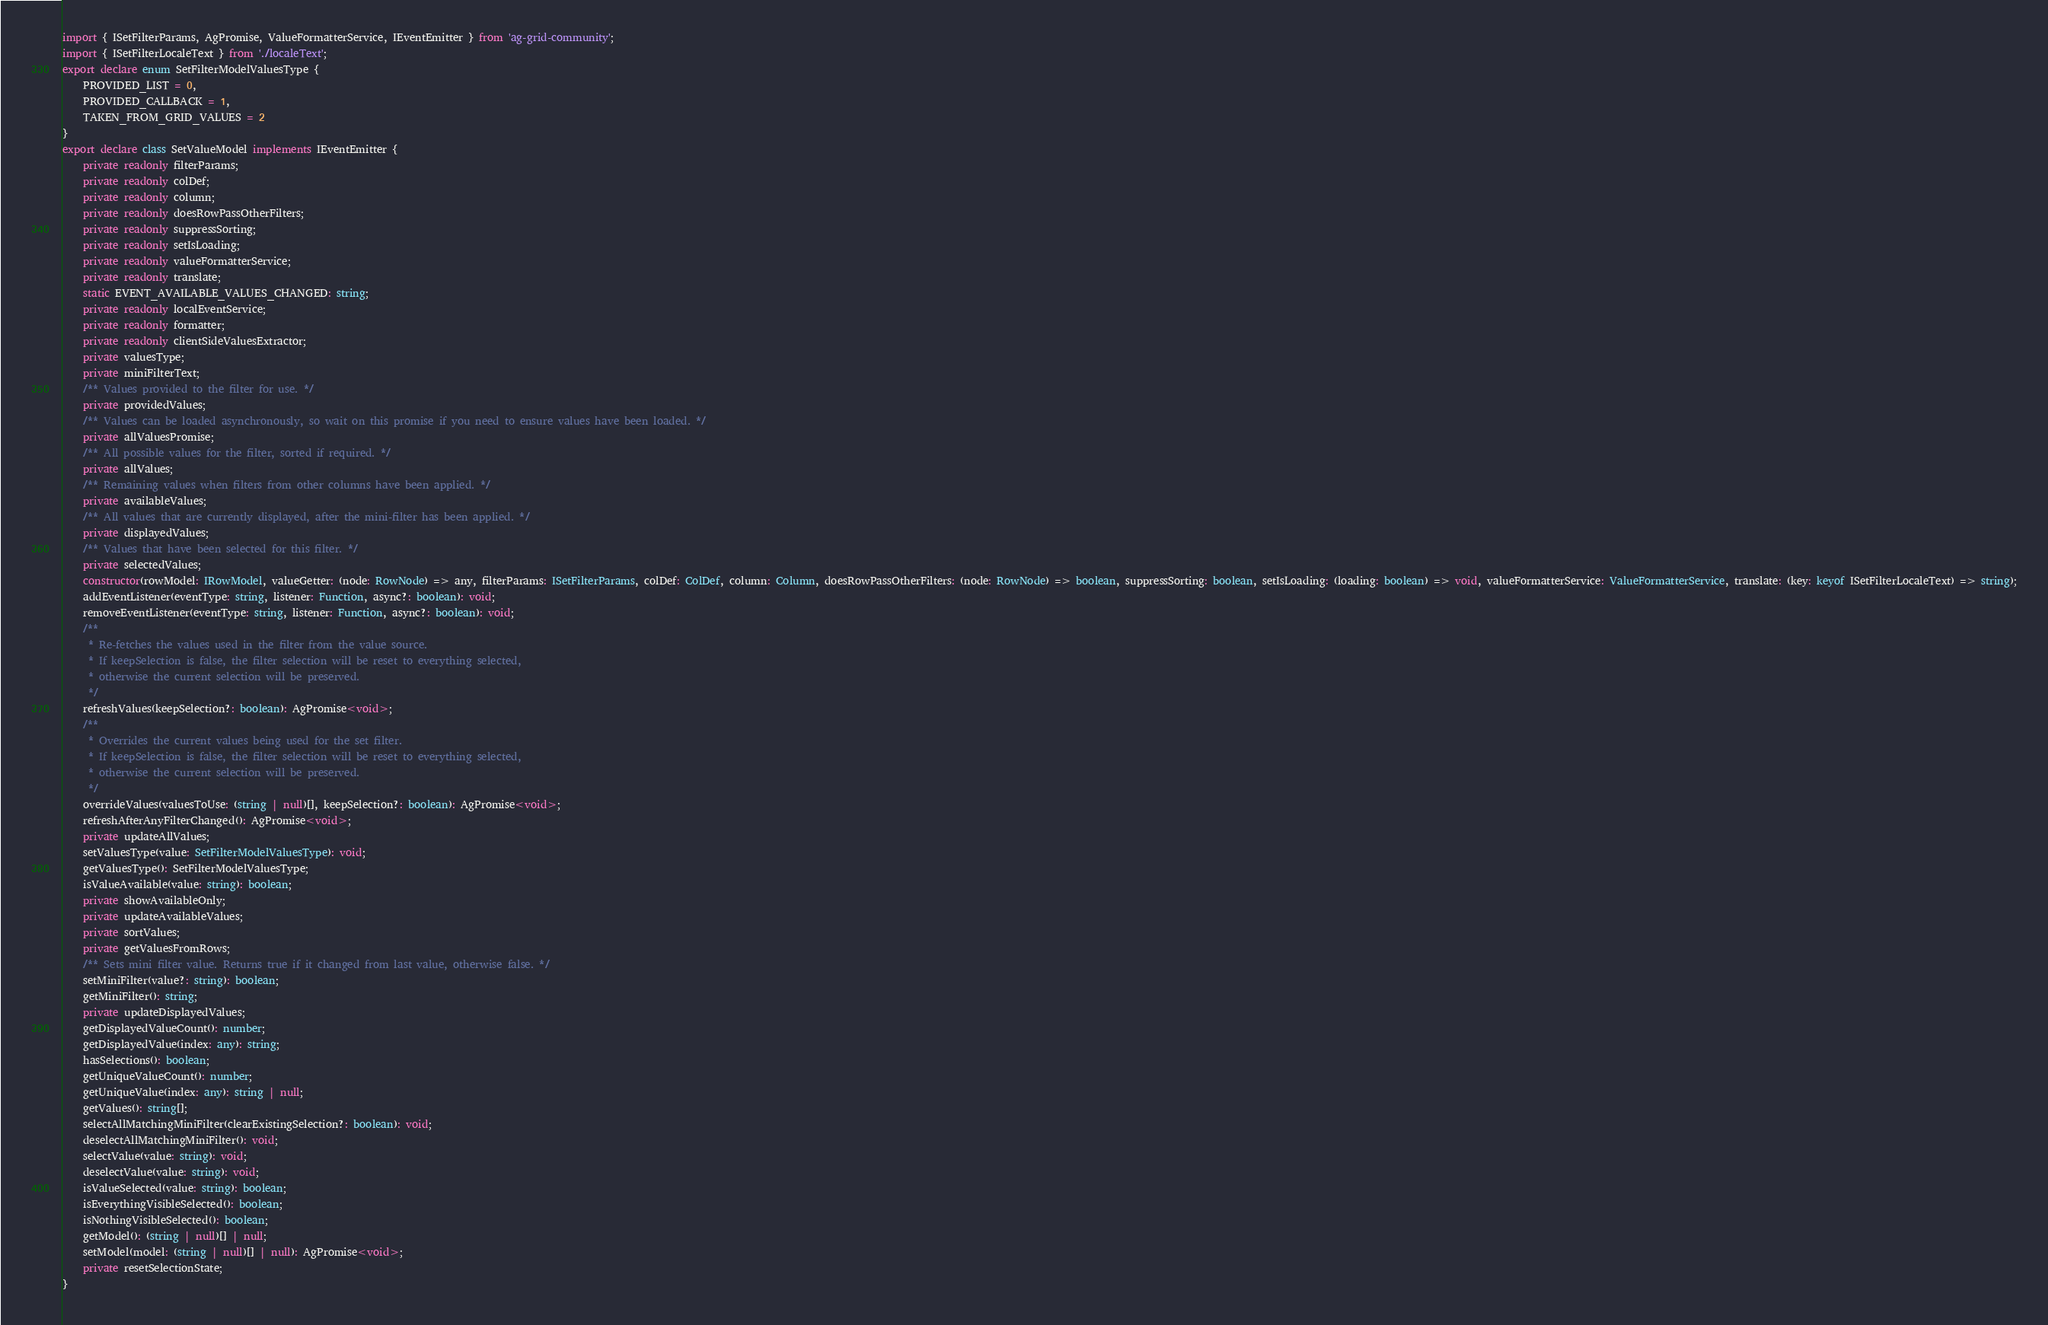<code> <loc_0><loc_0><loc_500><loc_500><_TypeScript_>import { ISetFilterParams, AgPromise, ValueFormatterService, IEventEmitter } from 'ag-grid-community';
import { ISetFilterLocaleText } from './localeText';
export declare enum SetFilterModelValuesType {
    PROVIDED_LIST = 0,
    PROVIDED_CALLBACK = 1,
    TAKEN_FROM_GRID_VALUES = 2
}
export declare class SetValueModel implements IEventEmitter {
    private readonly filterParams;
    private readonly colDef;
    private readonly column;
    private readonly doesRowPassOtherFilters;
    private readonly suppressSorting;
    private readonly setIsLoading;
    private readonly valueFormatterService;
    private readonly translate;
    static EVENT_AVAILABLE_VALUES_CHANGED: string;
    private readonly localEventService;
    private readonly formatter;
    private readonly clientSideValuesExtractor;
    private valuesType;
    private miniFilterText;
    /** Values provided to the filter for use. */
    private providedValues;
    /** Values can be loaded asynchronously, so wait on this promise if you need to ensure values have been loaded. */
    private allValuesPromise;
    /** All possible values for the filter, sorted if required. */
    private allValues;
    /** Remaining values when filters from other columns have been applied. */
    private availableValues;
    /** All values that are currently displayed, after the mini-filter has been applied. */
    private displayedValues;
    /** Values that have been selected for this filter. */
    private selectedValues;
    constructor(rowModel: IRowModel, valueGetter: (node: RowNode) => any, filterParams: ISetFilterParams, colDef: ColDef, column: Column, doesRowPassOtherFilters: (node: RowNode) => boolean, suppressSorting: boolean, setIsLoading: (loading: boolean) => void, valueFormatterService: ValueFormatterService, translate: (key: keyof ISetFilterLocaleText) => string);
    addEventListener(eventType: string, listener: Function, async?: boolean): void;
    removeEventListener(eventType: string, listener: Function, async?: boolean): void;
    /**
     * Re-fetches the values used in the filter from the value source.
     * If keepSelection is false, the filter selection will be reset to everything selected,
     * otherwise the current selection will be preserved.
     */
    refreshValues(keepSelection?: boolean): AgPromise<void>;
    /**
     * Overrides the current values being used for the set filter.
     * If keepSelection is false, the filter selection will be reset to everything selected,
     * otherwise the current selection will be preserved.
     */
    overrideValues(valuesToUse: (string | null)[], keepSelection?: boolean): AgPromise<void>;
    refreshAfterAnyFilterChanged(): AgPromise<void>;
    private updateAllValues;
    setValuesType(value: SetFilterModelValuesType): void;
    getValuesType(): SetFilterModelValuesType;
    isValueAvailable(value: string): boolean;
    private showAvailableOnly;
    private updateAvailableValues;
    private sortValues;
    private getValuesFromRows;
    /** Sets mini filter value. Returns true if it changed from last value, otherwise false. */
    setMiniFilter(value?: string): boolean;
    getMiniFilter(): string;
    private updateDisplayedValues;
    getDisplayedValueCount(): number;
    getDisplayedValue(index: any): string;
    hasSelections(): boolean;
    getUniqueValueCount(): number;
    getUniqueValue(index: any): string | null;
    getValues(): string[];
    selectAllMatchingMiniFilter(clearExistingSelection?: boolean): void;
    deselectAllMatchingMiniFilter(): void;
    selectValue(value: string): void;
    deselectValue(value: string): void;
    isValueSelected(value: string): boolean;
    isEverythingVisibleSelected(): boolean;
    isNothingVisibleSelected(): boolean;
    getModel(): (string | null)[] | null;
    setModel(model: (string | null)[] | null): AgPromise<void>;
    private resetSelectionState;
}
</code> 